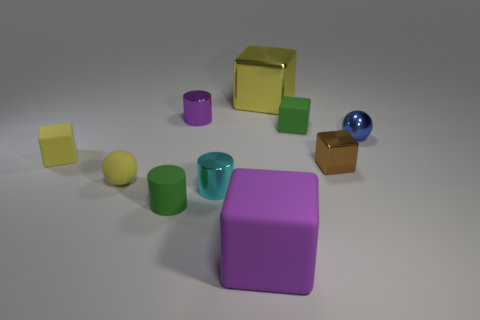Can you tell me about the different shapes present in this image? In the image, there are several three-dimensional shapes: cylinders, cubes, and a sphere. The cylinders have different heights and colors, with purple, green, and teal represented. The cubes are yellow and brown, and the sphere is blue with a reflective surface, adding variety to the mix of shapes. 